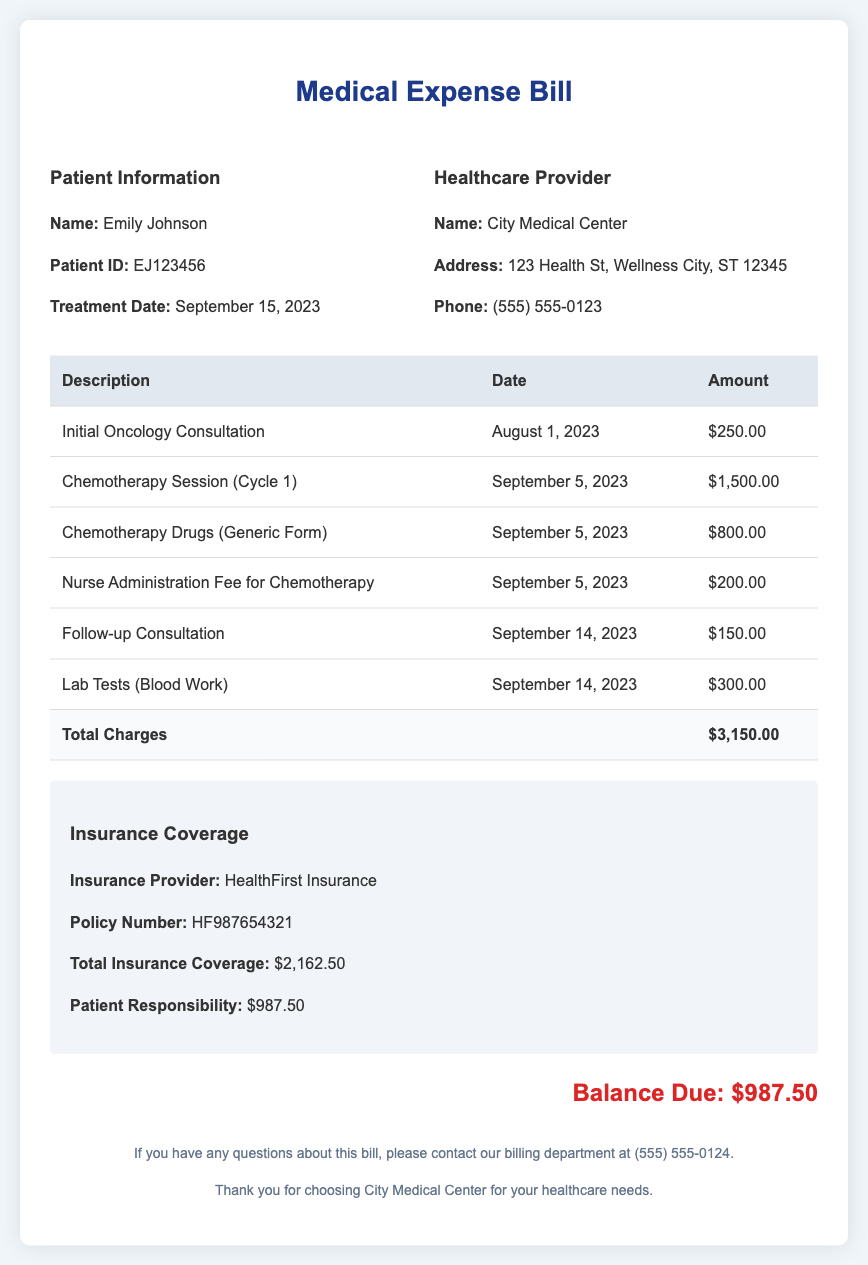what is the name of the patient? The patient's name is displayed in the Patient Information section of the document.
Answer: Emily Johnson when was the initial oncology consultation? The date of the initial oncology consultation is listed in the charges table.
Answer: August 1, 2023 what is the total amount charged for chemotherapy drugs? The total amount charged for chemotherapy drugs can be found in the charges table under the relevant description.
Answer: $800.00 what is the insurance provider's name? The insurance provider's name is mentioned in the Insurance Coverage section of the document.
Answer: HealthFirst Insurance how much is the patient’s responsibility after insurance? The patient's responsibility after insurance coverage is stated in the Insurance Coverage section.
Answer: $987.50 what is the total amount billed by City Medical Center? The total billed amount can be calculated from the charges listed in the document.
Answer: $3,150.00 what is the balance due? The balance due is highlighted at the end of the document.
Answer: $987.50 how many chemotherapy sessions are listed in the bill? The number of chemotherapy sessions can be counted from the charges table.
Answer: 1 what type of test is included in the bill? The type of test is provided under the charges section of the document.
Answer: Lab Tests (Blood Work) 